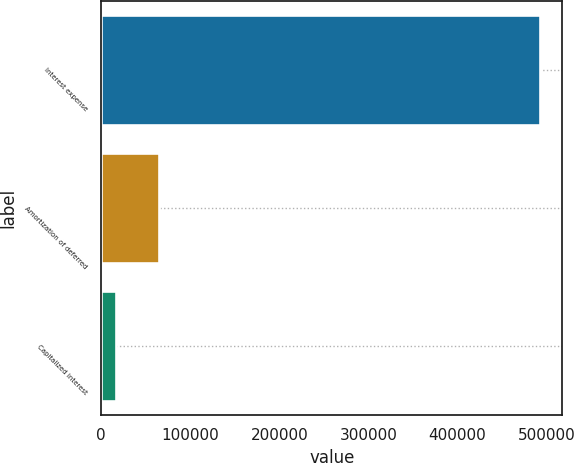Convert chart. <chart><loc_0><loc_0><loc_500><loc_500><bar_chart><fcel>Interest expense<fcel>Amortization of deferred<fcel>Capitalized interest<nl><fcel>493067<fcel>64427.6<fcel>16801<nl></chart> 